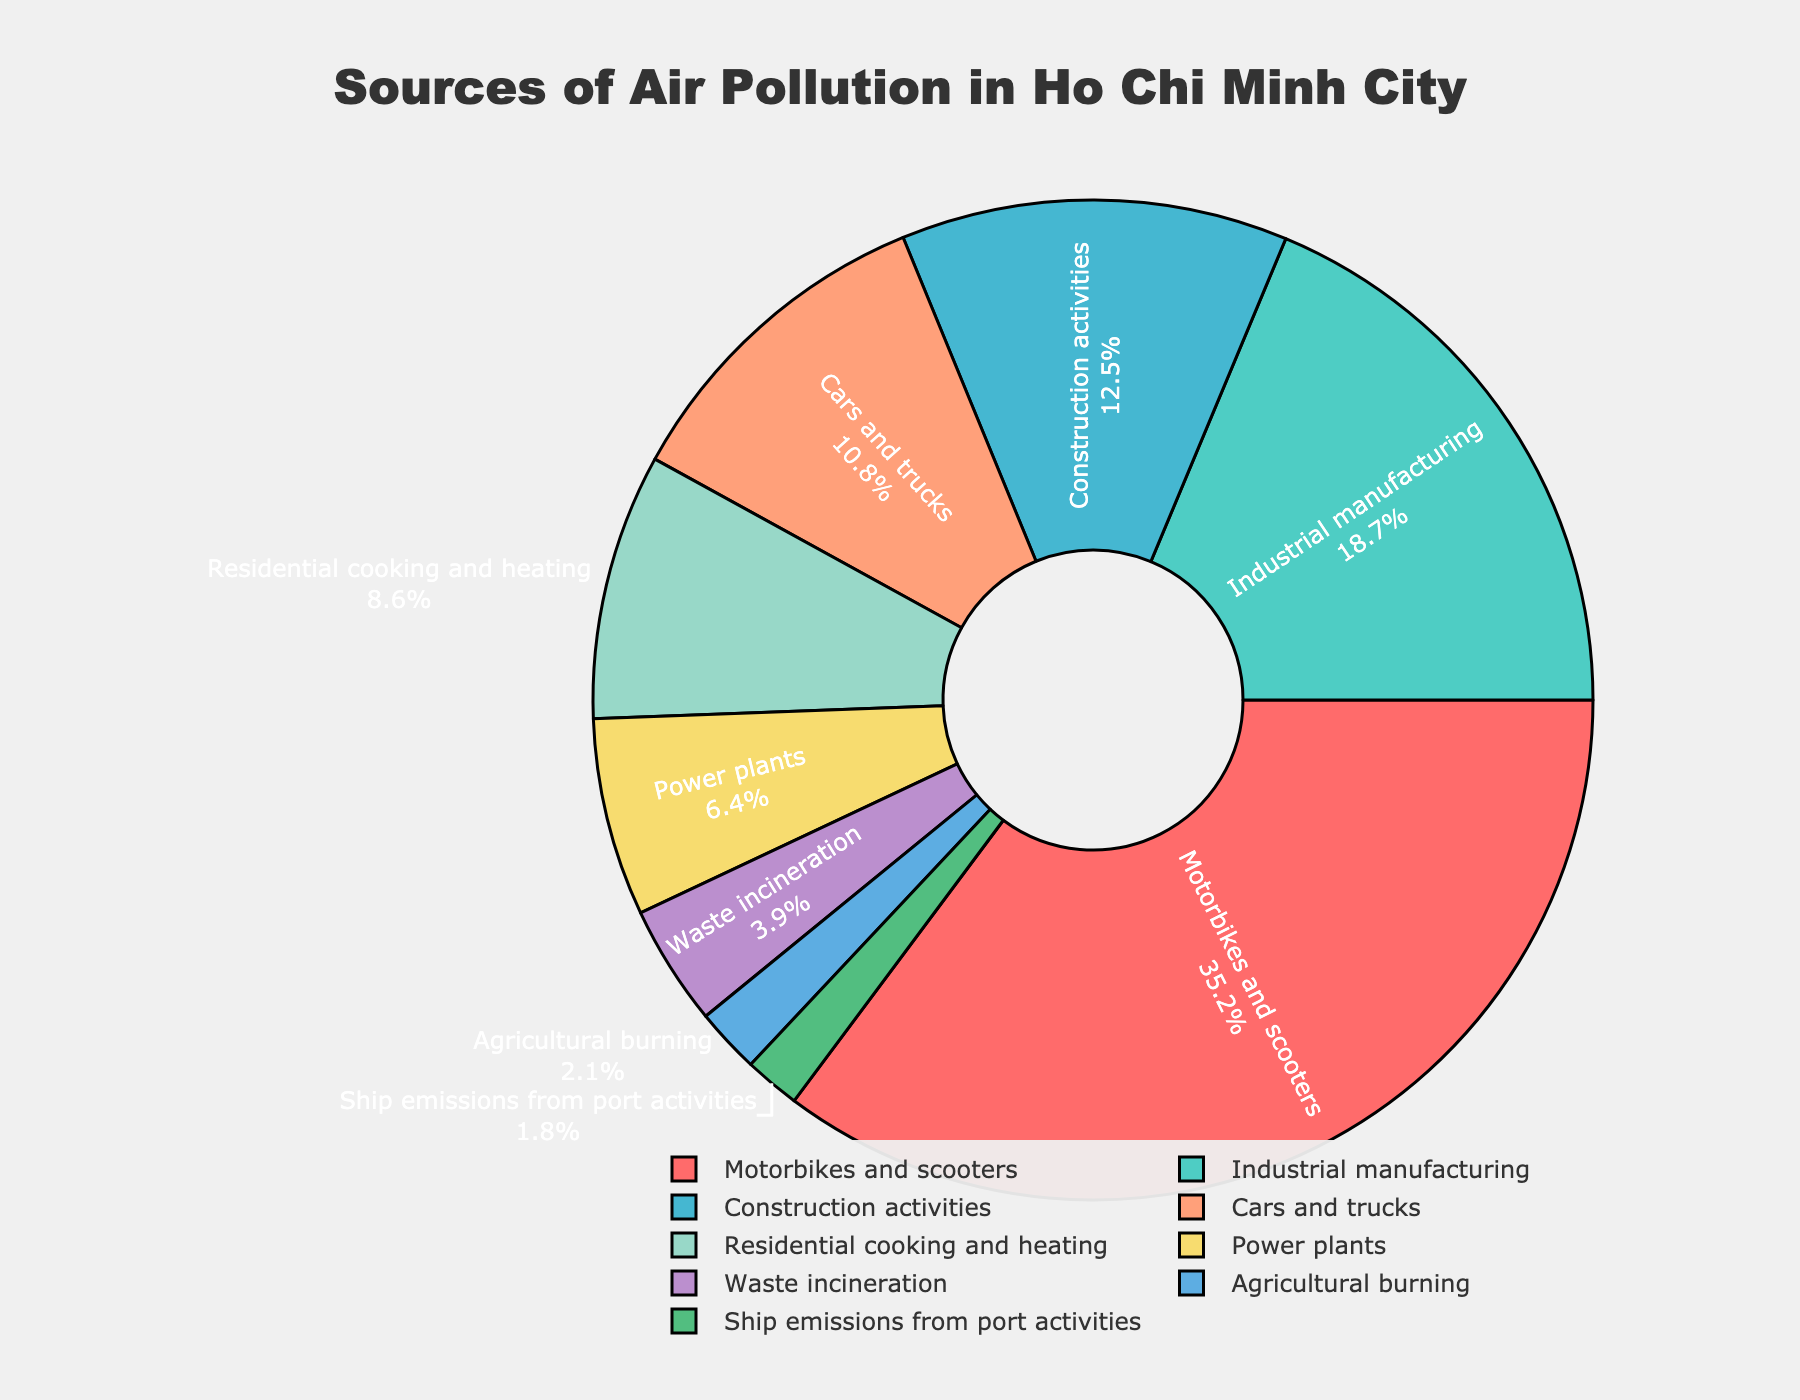What is the largest source of air pollution in Ho Chi Minh City? According to the pie chart, Motorbikes and scooters account for the largest percentage of air pollution at 35.2%.
Answer: Motorbikes and scooters Which source contributes the least to air pollution in Ho Chi Minh City? From the pie chart, Ship emissions from port activities contribute the least to air pollution at 1.8%.
Answer: Ship emissions from port activities How much more does Motorbikes and scooters contribute to air pollution compared to Cars and trucks? Motorbikes and scooters contribute 35.2%, and Cars and trucks contribute 10.8%. The difference is 35.2% - 10.8% = 24.4%.
Answer: 24.4% What is the total percentage of air pollution contributed by residential activities (Residential cooking and heating)? The percentage attributed to Residential cooking and heating is 8.6%.
Answer: 8.6% Which sources individually contribute more than 10% to air pollution? From the pie chart, the sources contributing more than 10% are Motorbikes and scooters (35.2%), Industrial manufacturing (18.7%), and Construction activities (12.5%).
Answer: Motorbikes and scooters, Industrial manufacturing, Construction activities What is the combined contribution of Power plants and Waste incineration to air pollution? Power plants contribute 6.4%, and Waste incineration contributes 3.9%. The combined contribution is 6.4% + 3.9% = 10.3%.
Answer: 10.3% By what factor does Construction activities' contribution to air pollution exceed Ship emissions from port activities? Construction activities contribute 12.5%, and Ship emissions from port activities contribute 1.8%. The factor is 12.5% / 1.8% ≈ 6.94.
Answer: Approximately 6.94 Rank the sources from highest to lowest based on their air pollution contribution percentages. The pie chart shows the sources ranked from highest to lowest as follows: 
1. Motorbikes and scooters (35.2%), 
2. Industrial manufacturing (18.7%), 
3. Construction activities (12.5%), 
4. Cars and trucks (10.8%), 
5. Residential cooking and heating (8.6%), 
6. Power plants (6.4%), 
7. Waste incineration (3.9%), 
8. Agricultural burning (2.1%), 
9. Ship emissions from port activities (1.8%).
Answer: Motorbikes and scooters, Industrial manufacturing, Construction activities, Cars and trucks, Residential cooking and heating, Power plants, Waste incineration, Agricultural burning, Ship emissions from port activities Is the sum of contributions from Agricultural burning and Ship emissions from port activities less than 5%? Agricultural burning contributes 2.1%, and Ship emissions from port activities contribute 1.8%. Their sum is 2.1% + 1.8% = 3.9%, which is less than 5%.
Answer: Yes Which color in the pie chart represents Motorbikes and scooters? The color representing Motorbikes and scooters in the pie chart appears to be red.
Answer: Red 